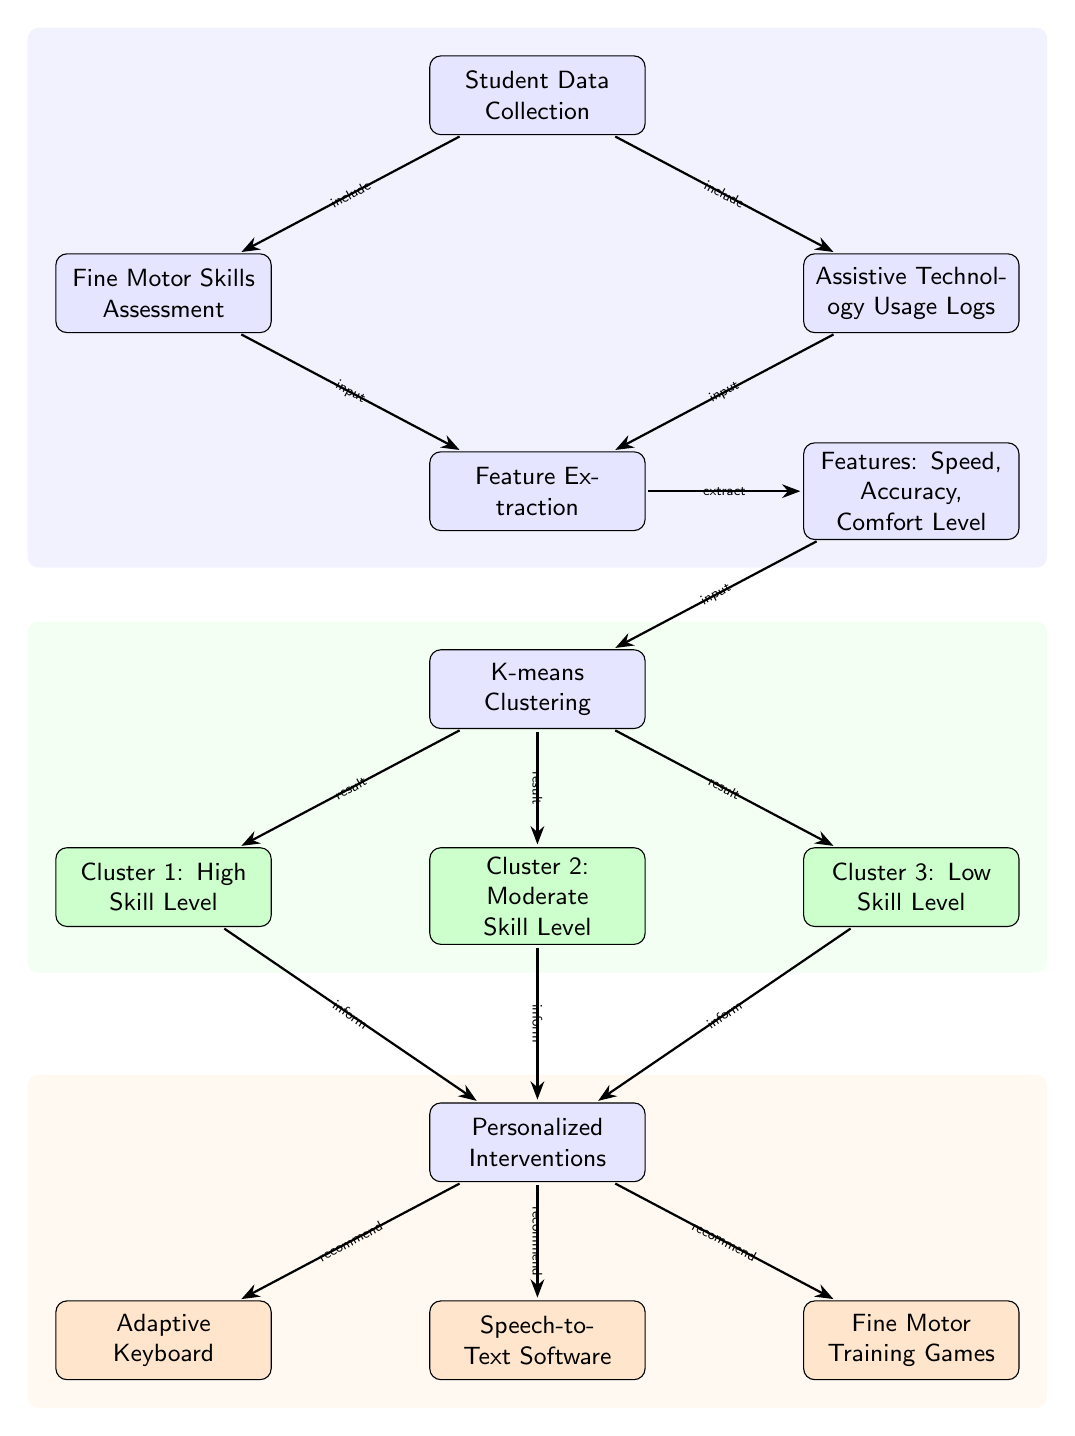What is the first step in this process? The first step is labeled as "Student Data Collection," which is the starting point of the diagram.
Answer: Student Data Collection How many clusters are formed in the K-means clustering step? There are three clusters identified: Cluster 1, Cluster 2, and Cluster 3.
Answer: 3 What feature is NOT mentioned in the feature extraction step? The features listed are Speed, Accuracy, and Comfort Level; thus, Fine Motor Skills is not mentioned as a feature here.
Answer: Fine Motor Skills What type of interventions are recommended after clustering? The interventions include Adaptive Keyboard, Speech-to-Text Software, and Fine Motor Training Games.
Answer: Adaptive Keyboard, Speech-to-Text Software, Fine Motor Training Games How do the clusters influence personalized interventions? Each cluster (High Skill Level, Moderate Skill Level, Low Skill Level) informs which personalized interventions are recommended to each student based on their skill level.
Answer: Inform What is the relationship between Assistive Technology Usage Logs and Feature Extraction? The Assistive Technology Usage Logs are indicated as providing input to the Feature Extraction process.
Answer: Input Which cluster is associated with the highest skill level? Cluster 1 is designated as the one indicating the highest skill level among the three groups.
Answer: Cluster 1 In how many steps does feature extraction occur? The diagram shows that feature extraction occurs in one step from the input data before moving to the K-means clustering step.
Answer: 1 